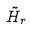Convert formula to latex. <formula><loc_0><loc_0><loc_500><loc_500>\tilde { H } _ { r }</formula> 